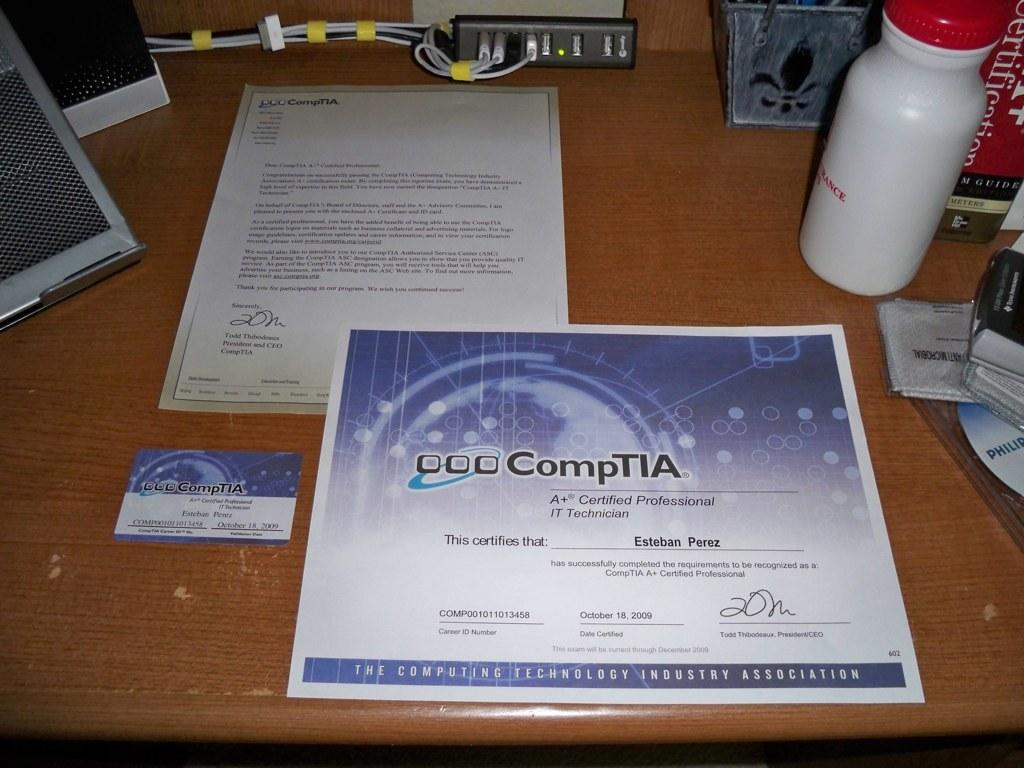<image>
Render a clear and concise summary of the photo. A desktop with assorted items and a CompTIA certificate. 